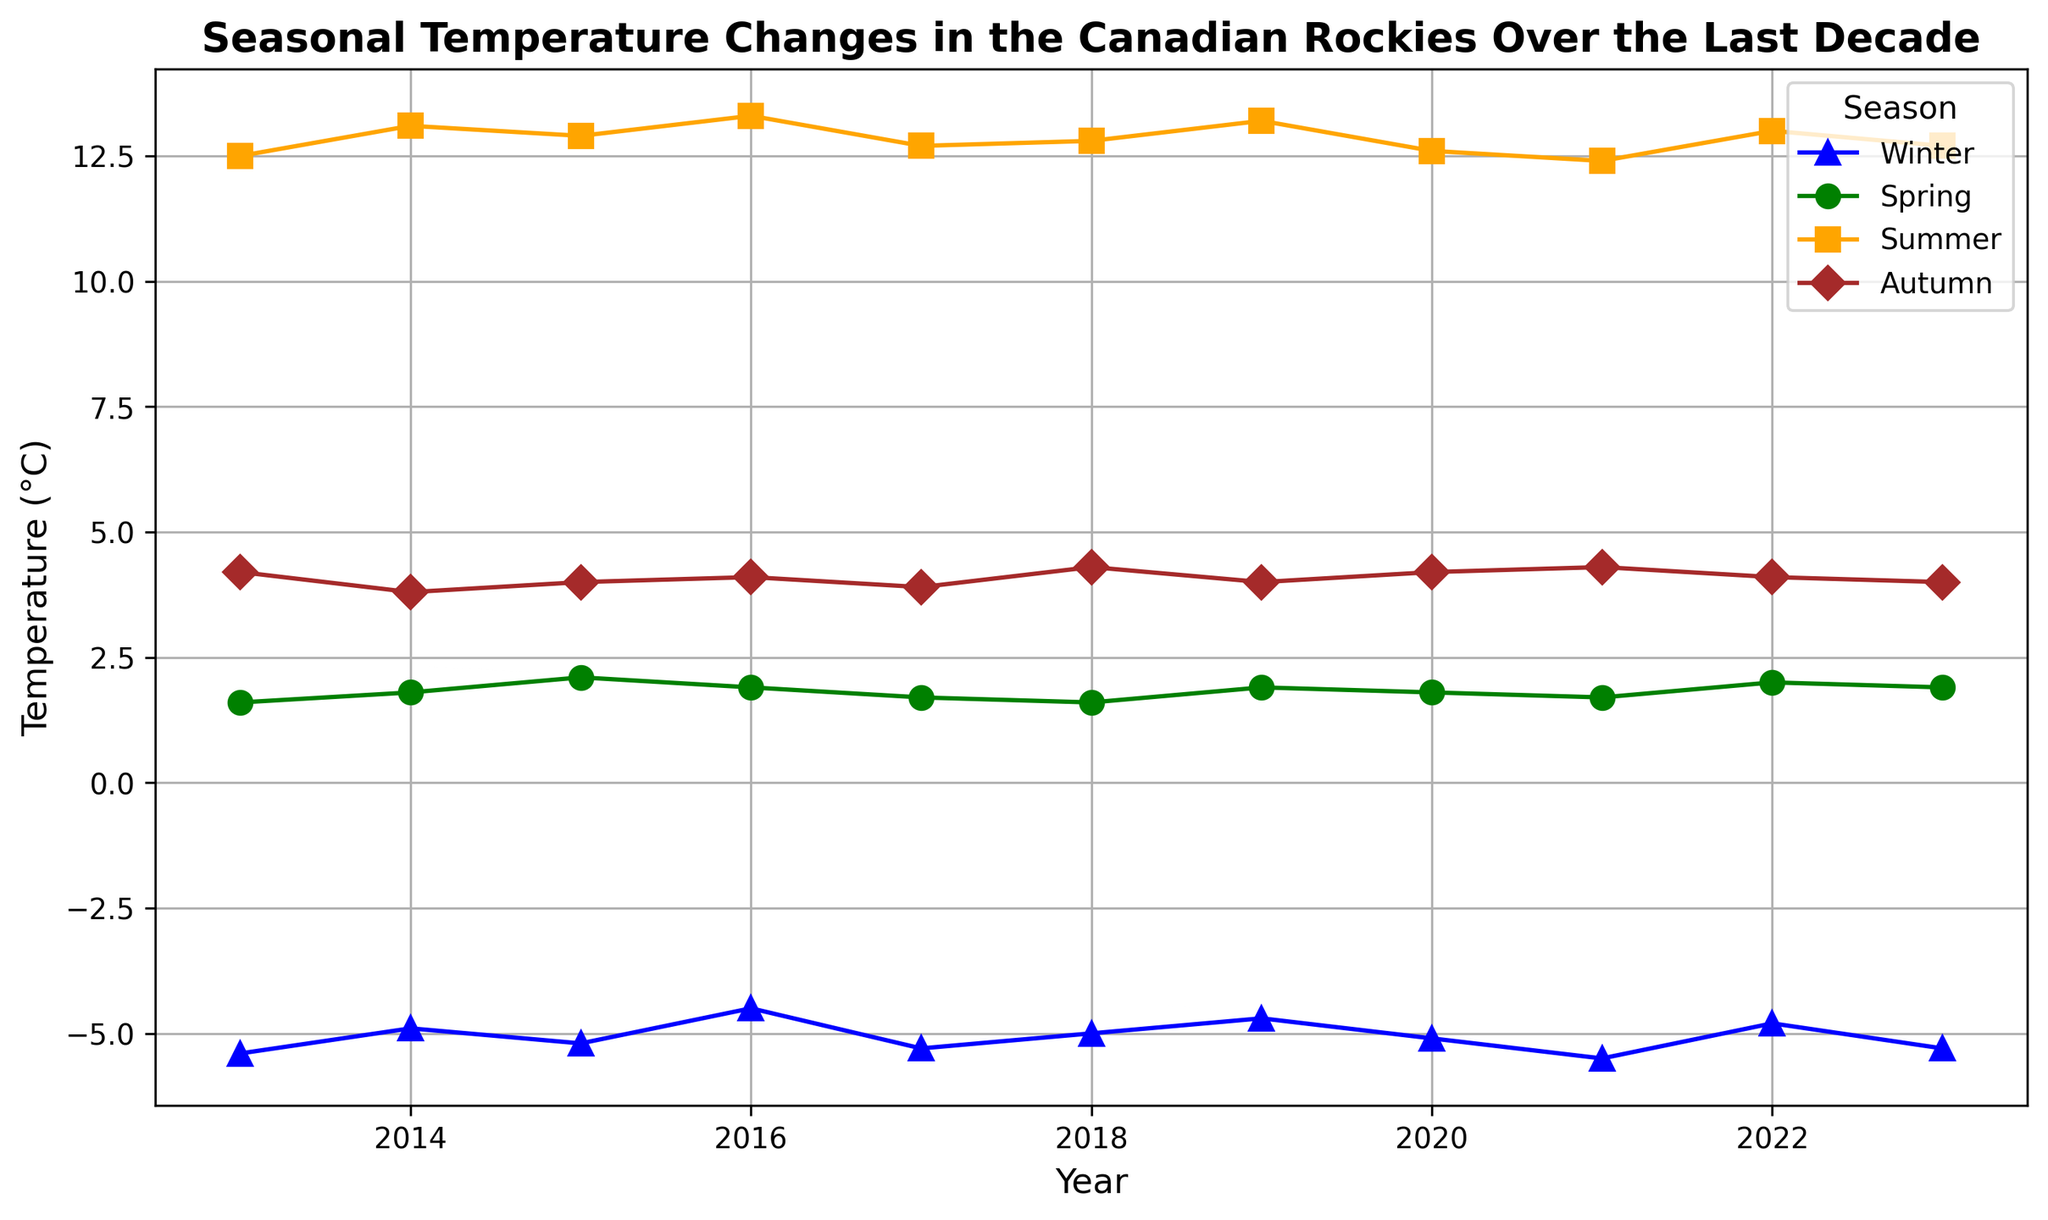What is the average winter temperature over the decade? To find this, sum up the winter temperatures for each year and divide by the number of years. The sum is (-5.4 + -4.9 + -5.2 + -4.5 + -5.3 + -5.0 + -4.7 + -5.1 + -5.5 + -4.8 + -5.3) = -55.7. Since there are 11 years, the average is -55.7 / 11.
Answer: -5.06°C Which season had the highest temperature in 2016? Look at the data points for the year 2016 and compare the temperatures for all four seasons. The temperatures are Winter: -4.5, Spring: 1.9, Summer: 13.3, Autumn: 4.1. The highest temperature is during Summer.
Answer: Summer What is the difference between the highest summer temperature and the lowest winter temperature in the dataset? Identify the highest summer temperature and the lowest winter temperature in the dataset. The highest summer temperature is 13.3°C (2016), and the lowest winter temperature is -5.5°C (2021). The difference is 13.3 - (-5.5) = 18.8°C.
Answer: 18.8°C Do autumn temperatures show an increasing or decreasing trend over the decade? Observe the line representing autumn temperatures from 2013 to 2023. The points are 4.2, 3.8, 4.0, 4.1, 3.9, 4.3, 4.0, 4.2, 4.3, 4.1, 4.0. The general trend appears to be stable without significant upward or downward movement.
Answer: Stable Which year had the largest range of temperatures across all seasons? Calculate the range for each year by subtracting the lowest temperature from the highest temperature for that year. For 2013: 12.5 - (-5.4) = 17.9, For 2014: 13.1 - (-4.9) = 18, etc. The largest range is in 2014 with a value of 18.
Answer: 2014 Is there any year where the spring temperature was higher than the autumn temperature? Compare spring and autumn temperatures for each year. For 2013: 1.6 > 4.2 (False), for 2014: 1.8 > 3.8 (False), and continue for all years. No such year is observed in the dataset.
Answer: No What is the median summer temperature over the decade? Order the summer temperatures and find the middle value. The ordered summer temperatures are: 12.4, 12.5, 12.6, 12.7, 12.7, 12.8, 12.8, 12.9, 13.0, 13.1, 13.2, 13.3. The median is the 6th value, 12.8°C.
Answer: 12.8°C 